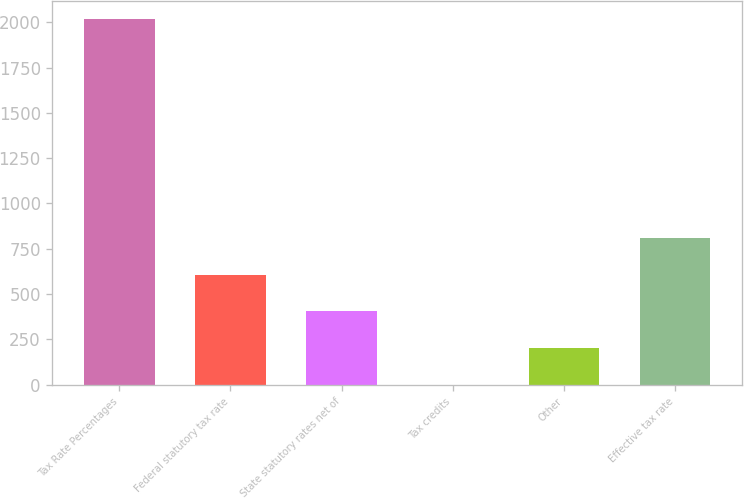Convert chart. <chart><loc_0><loc_0><loc_500><loc_500><bar_chart><fcel>Tax Rate Percentages<fcel>Federal statutory tax rate<fcel>State statutory rates net of<fcel>Tax credits<fcel>Other<fcel>Effective tax rate<nl><fcel>2017<fcel>605.17<fcel>403.48<fcel>0.1<fcel>201.79<fcel>806.86<nl></chart> 